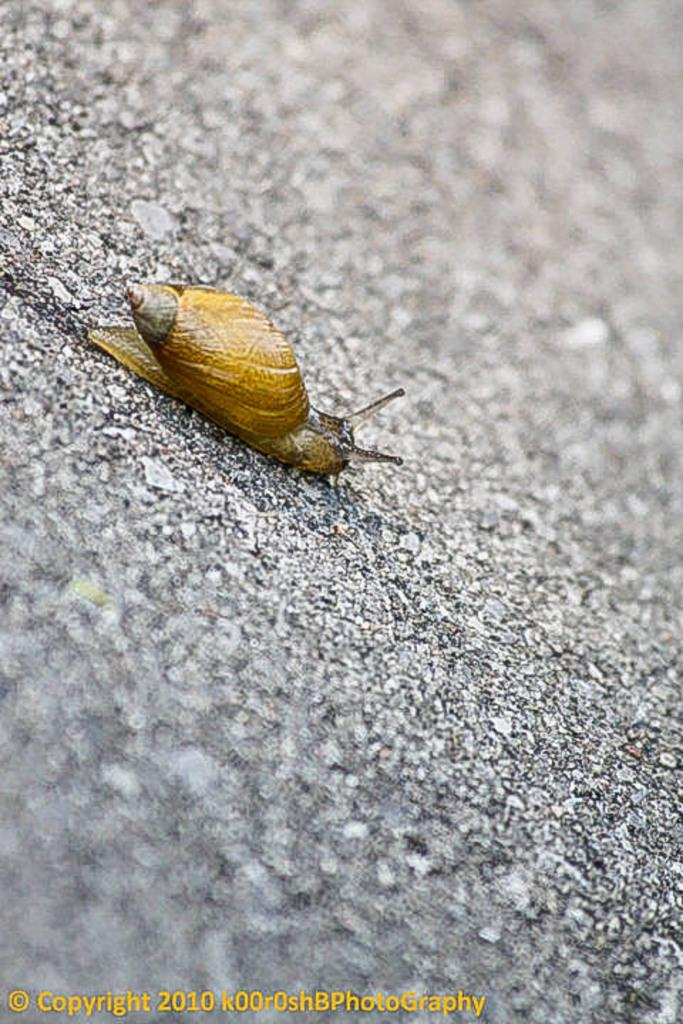What type of creature can be seen in the image? There is an insect in the image. Where is the insect located in the image? The insect is on the surface of the ground. Is there a woman in the image riding a carriage? There is no woman or carriage present in the image; it features an insect on the surface of the ground. 